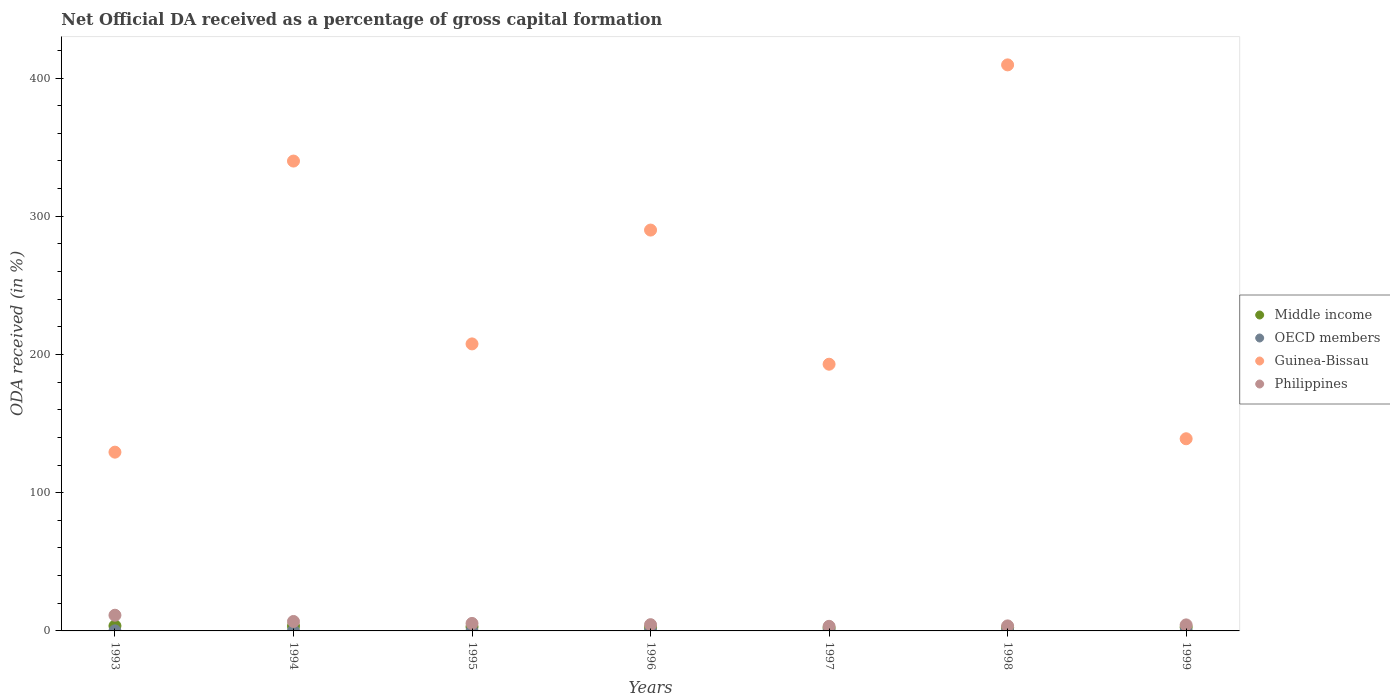How many different coloured dotlines are there?
Ensure brevity in your answer.  4. Is the number of dotlines equal to the number of legend labels?
Your answer should be compact. Yes. What is the net ODA received in Philippines in 1999?
Keep it short and to the point. 4.36. Across all years, what is the maximum net ODA received in Middle income?
Offer a terse response. 3.64. Across all years, what is the minimum net ODA received in Philippines?
Ensure brevity in your answer.  3.33. In which year was the net ODA received in OECD members maximum?
Make the answer very short. 1996. In which year was the net ODA received in Philippines minimum?
Make the answer very short. 1997. What is the total net ODA received in Guinea-Bissau in the graph?
Your answer should be compact. 1708.31. What is the difference between the net ODA received in Guinea-Bissau in 1995 and that in 1997?
Your response must be concise. 14.7. What is the difference between the net ODA received in OECD members in 1993 and the net ODA received in Philippines in 1999?
Your answer should be compact. -4.31. What is the average net ODA received in Philippines per year?
Give a very brief answer. 5.64. In the year 1997, what is the difference between the net ODA received in Philippines and net ODA received in Guinea-Bissau?
Give a very brief answer. -189.61. What is the ratio of the net ODA received in OECD members in 1996 to that in 1997?
Provide a succinct answer. 16.59. Is the difference between the net ODA received in Philippines in 1993 and 1997 greater than the difference between the net ODA received in Guinea-Bissau in 1993 and 1997?
Provide a succinct answer. Yes. What is the difference between the highest and the second highest net ODA received in Philippines?
Your answer should be very brief. 4.52. What is the difference between the highest and the lowest net ODA received in Guinea-Bissau?
Your answer should be compact. 280.17. In how many years, is the net ODA received in Guinea-Bissau greater than the average net ODA received in Guinea-Bissau taken over all years?
Make the answer very short. 3. Is it the case that in every year, the sum of the net ODA received in Middle income and net ODA received in Philippines  is greater than the net ODA received in OECD members?
Provide a short and direct response. Yes. How many dotlines are there?
Make the answer very short. 4. Are the values on the major ticks of Y-axis written in scientific E-notation?
Give a very brief answer. No. Does the graph contain grids?
Your answer should be very brief. No. How are the legend labels stacked?
Make the answer very short. Vertical. What is the title of the graph?
Keep it short and to the point. Net Official DA received as a percentage of gross capital formation. Does "Pacific island small states" appear as one of the legend labels in the graph?
Offer a terse response. No. What is the label or title of the Y-axis?
Make the answer very short. ODA received (in %). What is the ODA received (in %) in Middle income in 1993?
Provide a short and direct response. 3.64. What is the ODA received (in %) of OECD members in 1993?
Your answer should be very brief. 0.05. What is the ODA received (in %) of Guinea-Bissau in 1993?
Offer a very short reply. 129.32. What is the ODA received (in %) of Philippines in 1993?
Your answer should be compact. 11.35. What is the ODA received (in %) of Middle income in 1994?
Ensure brevity in your answer.  3.43. What is the ODA received (in %) of OECD members in 1994?
Give a very brief answer. 0.04. What is the ODA received (in %) in Guinea-Bissau in 1994?
Your answer should be compact. 339.91. What is the ODA received (in %) in Philippines in 1994?
Make the answer very short. 6.83. What is the ODA received (in %) of Middle income in 1995?
Give a very brief answer. 2.93. What is the ODA received (in %) of OECD members in 1995?
Make the answer very short. 0.02. What is the ODA received (in %) of Guinea-Bissau in 1995?
Ensure brevity in your answer.  207.64. What is the ODA received (in %) in Philippines in 1995?
Provide a short and direct response. 5.42. What is the ODA received (in %) in Middle income in 1996?
Your response must be concise. 2.51. What is the ODA received (in %) in OECD members in 1996?
Give a very brief answer. 0.05. What is the ODA received (in %) in Guinea-Bissau in 1996?
Your response must be concise. 289.99. What is the ODA received (in %) of Philippines in 1996?
Your answer should be very brief. 4.51. What is the ODA received (in %) of Middle income in 1997?
Keep it short and to the point. 2.09. What is the ODA received (in %) of OECD members in 1997?
Provide a succinct answer. 0. What is the ODA received (in %) of Guinea-Bissau in 1997?
Provide a short and direct response. 192.94. What is the ODA received (in %) of Philippines in 1997?
Keep it short and to the point. 3.33. What is the ODA received (in %) of Middle income in 1998?
Your response must be concise. 2.4. What is the ODA received (in %) of OECD members in 1998?
Make the answer very short. 0. What is the ODA received (in %) of Guinea-Bissau in 1998?
Provide a short and direct response. 409.5. What is the ODA received (in %) in Philippines in 1998?
Ensure brevity in your answer.  3.64. What is the ODA received (in %) in Middle income in 1999?
Your answer should be compact. 2.69. What is the ODA received (in %) of OECD members in 1999?
Offer a very short reply. 0. What is the ODA received (in %) in Guinea-Bissau in 1999?
Keep it short and to the point. 139.02. What is the ODA received (in %) in Philippines in 1999?
Offer a terse response. 4.36. Across all years, what is the maximum ODA received (in %) of Middle income?
Ensure brevity in your answer.  3.64. Across all years, what is the maximum ODA received (in %) of OECD members?
Ensure brevity in your answer.  0.05. Across all years, what is the maximum ODA received (in %) of Guinea-Bissau?
Your answer should be very brief. 409.5. Across all years, what is the maximum ODA received (in %) in Philippines?
Make the answer very short. 11.35. Across all years, what is the minimum ODA received (in %) of Middle income?
Make the answer very short. 2.09. Across all years, what is the minimum ODA received (in %) of OECD members?
Your response must be concise. 0. Across all years, what is the minimum ODA received (in %) of Guinea-Bissau?
Offer a terse response. 129.32. Across all years, what is the minimum ODA received (in %) of Philippines?
Provide a succinct answer. 3.33. What is the total ODA received (in %) in Middle income in the graph?
Your answer should be very brief. 19.69. What is the total ODA received (in %) in OECD members in the graph?
Your response must be concise. 0.16. What is the total ODA received (in %) in Guinea-Bissau in the graph?
Your response must be concise. 1708.31. What is the total ODA received (in %) of Philippines in the graph?
Provide a succinct answer. 39.45. What is the difference between the ODA received (in %) in Middle income in 1993 and that in 1994?
Give a very brief answer. 0.22. What is the difference between the ODA received (in %) in OECD members in 1993 and that in 1994?
Keep it short and to the point. 0.01. What is the difference between the ODA received (in %) in Guinea-Bissau in 1993 and that in 1994?
Your answer should be compact. -210.58. What is the difference between the ODA received (in %) in Philippines in 1993 and that in 1994?
Ensure brevity in your answer.  4.52. What is the difference between the ODA received (in %) in Middle income in 1993 and that in 1995?
Provide a short and direct response. 0.71. What is the difference between the ODA received (in %) in OECD members in 1993 and that in 1995?
Keep it short and to the point. 0.02. What is the difference between the ODA received (in %) of Guinea-Bissau in 1993 and that in 1995?
Provide a succinct answer. -78.31. What is the difference between the ODA received (in %) in Philippines in 1993 and that in 1995?
Offer a terse response. 5.93. What is the difference between the ODA received (in %) in Middle income in 1993 and that in 1996?
Your answer should be compact. 1.14. What is the difference between the ODA received (in %) of OECD members in 1993 and that in 1996?
Provide a short and direct response. -0. What is the difference between the ODA received (in %) of Guinea-Bissau in 1993 and that in 1996?
Offer a terse response. -160.66. What is the difference between the ODA received (in %) of Philippines in 1993 and that in 1996?
Make the answer very short. 6.84. What is the difference between the ODA received (in %) in Middle income in 1993 and that in 1997?
Make the answer very short. 1.55. What is the difference between the ODA received (in %) of OECD members in 1993 and that in 1997?
Provide a short and direct response. 0.04. What is the difference between the ODA received (in %) in Guinea-Bissau in 1993 and that in 1997?
Your answer should be compact. -63.62. What is the difference between the ODA received (in %) of Philippines in 1993 and that in 1997?
Provide a succinct answer. 8.02. What is the difference between the ODA received (in %) of Middle income in 1993 and that in 1998?
Offer a terse response. 1.25. What is the difference between the ODA received (in %) in OECD members in 1993 and that in 1998?
Give a very brief answer. 0.04. What is the difference between the ODA received (in %) of Guinea-Bissau in 1993 and that in 1998?
Ensure brevity in your answer.  -280.17. What is the difference between the ODA received (in %) in Philippines in 1993 and that in 1998?
Your answer should be compact. 7.72. What is the difference between the ODA received (in %) of Middle income in 1993 and that in 1999?
Give a very brief answer. 0.95. What is the difference between the ODA received (in %) in OECD members in 1993 and that in 1999?
Provide a short and direct response. 0.05. What is the difference between the ODA received (in %) in Guinea-Bissau in 1993 and that in 1999?
Your answer should be very brief. -9.7. What is the difference between the ODA received (in %) of Philippines in 1993 and that in 1999?
Your answer should be compact. 6.99. What is the difference between the ODA received (in %) of Middle income in 1994 and that in 1995?
Offer a terse response. 0.5. What is the difference between the ODA received (in %) in OECD members in 1994 and that in 1995?
Keep it short and to the point. 0.01. What is the difference between the ODA received (in %) in Guinea-Bissau in 1994 and that in 1995?
Keep it short and to the point. 132.27. What is the difference between the ODA received (in %) in Philippines in 1994 and that in 1995?
Your answer should be very brief. 1.41. What is the difference between the ODA received (in %) in Middle income in 1994 and that in 1996?
Ensure brevity in your answer.  0.92. What is the difference between the ODA received (in %) in OECD members in 1994 and that in 1996?
Your response must be concise. -0.01. What is the difference between the ODA received (in %) of Guinea-Bissau in 1994 and that in 1996?
Your response must be concise. 49.92. What is the difference between the ODA received (in %) in Philippines in 1994 and that in 1996?
Give a very brief answer. 2.32. What is the difference between the ODA received (in %) in Middle income in 1994 and that in 1997?
Provide a succinct answer. 1.33. What is the difference between the ODA received (in %) of OECD members in 1994 and that in 1997?
Ensure brevity in your answer.  0.03. What is the difference between the ODA received (in %) of Guinea-Bissau in 1994 and that in 1997?
Your response must be concise. 146.97. What is the difference between the ODA received (in %) of Philippines in 1994 and that in 1997?
Your response must be concise. 3.5. What is the difference between the ODA received (in %) in Middle income in 1994 and that in 1998?
Ensure brevity in your answer.  1.03. What is the difference between the ODA received (in %) of OECD members in 1994 and that in 1998?
Offer a terse response. 0.03. What is the difference between the ODA received (in %) of Guinea-Bissau in 1994 and that in 1998?
Offer a terse response. -69.59. What is the difference between the ODA received (in %) of Philippines in 1994 and that in 1998?
Your answer should be compact. 3.2. What is the difference between the ODA received (in %) in Middle income in 1994 and that in 1999?
Your response must be concise. 0.74. What is the difference between the ODA received (in %) in OECD members in 1994 and that in 1999?
Provide a succinct answer. 0.04. What is the difference between the ODA received (in %) of Guinea-Bissau in 1994 and that in 1999?
Keep it short and to the point. 200.89. What is the difference between the ODA received (in %) of Philippines in 1994 and that in 1999?
Give a very brief answer. 2.47. What is the difference between the ODA received (in %) in Middle income in 1995 and that in 1996?
Ensure brevity in your answer.  0.42. What is the difference between the ODA received (in %) in OECD members in 1995 and that in 1996?
Ensure brevity in your answer.  -0.03. What is the difference between the ODA received (in %) of Guinea-Bissau in 1995 and that in 1996?
Offer a terse response. -82.35. What is the difference between the ODA received (in %) in Philippines in 1995 and that in 1996?
Keep it short and to the point. 0.91. What is the difference between the ODA received (in %) of Middle income in 1995 and that in 1997?
Your answer should be very brief. 0.84. What is the difference between the ODA received (in %) in OECD members in 1995 and that in 1997?
Your answer should be very brief. 0.02. What is the difference between the ODA received (in %) of Guinea-Bissau in 1995 and that in 1997?
Your response must be concise. 14.7. What is the difference between the ODA received (in %) in Philippines in 1995 and that in 1997?
Offer a very short reply. 2.09. What is the difference between the ODA received (in %) in Middle income in 1995 and that in 1998?
Give a very brief answer. 0.53. What is the difference between the ODA received (in %) of OECD members in 1995 and that in 1998?
Your response must be concise. 0.02. What is the difference between the ODA received (in %) of Guinea-Bissau in 1995 and that in 1998?
Offer a very short reply. -201.86. What is the difference between the ODA received (in %) in Philippines in 1995 and that in 1998?
Give a very brief answer. 1.79. What is the difference between the ODA received (in %) of Middle income in 1995 and that in 1999?
Give a very brief answer. 0.24. What is the difference between the ODA received (in %) in OECD members in 1995 and that in 1999?
Ensure brevity in your answer.  0.02. What is the difference between the ODA received (in %) of Guinea-Bissau in 1995 and that in 1999?
Keep it short and to the point. 68.62. What is the difference between the ODA received (in %) in Philippines in 1995 and that in 1999?
Provide a succinct answer. 1.06. What is the difference between the ODA received (in %) in Middle income in 1996 and that in 1997?
Ensure brevity in your answer.  0.41. What is the difference between the ODA received (in %) in OECD members in 1996 and that in 1997?
Provide a short and direct response. 0.05. What is the difference between the ODA received (in %) of Guinea-Bissau in 1996 and that in 1997?
Your response must be concise. 97.05. What is the difference between the ODA received (in %) in Philippines in 1996 and that in 1997?
Your response must be concise. 1.18. What is the difference between the ODA received (in %) of Middle income in 1996 and that in 1998?
Offer a very short reply. 0.11. What is the difference between the ODA received (in %) of OECD members in 1996 and that in 1998?
Keep it short and to the point. 0.05. What is the difference between the ODA received (in %) in Guinea-Bissau in 1996 and that in 1998?
Your answer should be very brief. -119.51. What is the difference between the ODA received (in %) in Philippines in 1996 and that in 1998?
Your answer should be compact. 0.88. What is the difference between the ODA received (in %) in Middle income in 1996 and that in 1999?
Keep it short and to the point. -0.18. What is the difference between the ODA received (in %) of OECD members in 1996 and that in 1999?
Your answer should be compact. 0.05. What is the difference between the ODA received (in %) in Guinea-Bissau in 1996 and that in 1999?
Ensure brevity in your answer.  150.97. What is the difference between the ODA received (in %) of Philippines in 1996 and that in 1999?
Keep it short and to the point. 0.15. What is the difference between the ODA received (in %) of Middle income in 1997 and that in 1998?
Provide a succinct answer. -0.3. What is the difference between the ODA received (in %) in OECD members in 1997 and that in 1998?
Make the answer very short. 0. What is the difference between the ODA received (in %) in Guinea-Bissau in 1997 and that in 1998?
Make the answer very short. -216.56. What is the difference between the ODA received (in %) in Philippines in 1997 and that in 1998?
Your response must be concise. -0.3. What is the difference between the ODA received (in %) in Middle income in 1997 and that in 1999?
Provide a succinct answer. -0.6. What is the difference between the ODA received (in %) in OECD members in 1997 and that in 1999?
Keep it short and to the point. 0. What is the difference between the ODA received (in %) in Guinea-Bissau in 1997 and that in 1999?
Provide a succinct answer. 53.92. What is the difference between the ODA received (in %) in Philippines in 1997 and that in 1999?
Give a very brief answer. -1.03. What is the difference between the ODA received (in %) of Middle income in 1998 and that in 1999?
Your response must be concise. -0.29. What is the difference between the ODA received (in %) in OECD members in 1998 and that in 1999?
Ensure brevity in your answer.  0. What is the difference between the ODA received (in %) of Guinea-Bissau in 1998 and that in 1999?
Offer a very short reply. 270.48. What is the difference between the ODA received (in %) of Philippines in 1998 and that in 1999?
Keep it short and to the point. -0.73. What is the difference between the ODA received (in %) in Middle income in 1993 and the ODA received (in %) in OECD members in 1994?
Keep it short and to the point. 3.61. What is the difference between the ODA received (in %) of Middle income in 1993 and the ODA received (in %) of Guinea-Bissau in 1994?
Keep it short and to the point. -336.26. What is the difference between the ODA received (in %) in Middle income in 1993 and the ODA received (in %) in Philippines in 1994?
Provide a succinct answer. -3.19. What is the difference between the ODA received (in %) of OECD members in 1993 and the ODA received (in %) of Guinea-Bissau in 1994?
Your answer should be very brief. -339.86. What is the difference between the ODA received (in %) of OECD members in 1993 and the ODA received (in %) of Philippines in 1994?
Keep it short and to the point. -6.79. What is the difference between the ODA received (in %) in Guinea-Bissau in 1993 and the ODA received (in %) in Philippines in 1994?
Offer a terse response. 122.49. What is the difference between the ODA received (in %) of Middle income in 1993 and the ODA received (in %) of OECD members in 1995?
Offer a terse response. 3.62. What is the difference between the ODA received (in %) in Middle income in 1993 and the ODA received (in %) in Guinea-Bissau in 1995?
Provide a succinct answer. -203.99. What is the difference between the ODA received (in %) of Middle income in 1993 and the ODA received (in %) of Philippines in 1995?
Provide a succinct answer. -1.78. What is the difference between the ODA received (in %) in OECD members in 1993 and the ODA received (in %) in Guinea-Bissau in 1995?
Make the answer very short. -207.59. What is the difference between the ODA received (in %) in OECD members in 1993 and the ODA received (in %) in Philippines in 1995?
Make the answer very short. -5.38. What is the difference between the ODA received (in %) of Guinea-Bissau in 1993 and the ODA received (in %) of Philippines in 1995?
Provide a succinct answer. 123.9. What is the difference between the ODA received (in %) of Middle income in 1993 and the ODA received (in %) of OECD members in 1996?
Your answer should be compact. 3.6. What is the difference between the ODA received (in %) of Middle income in 1993 and the ODA received (in %) of Guinea-Bissau in 1996?
Your answer should be very brief. -286.34. What is the difference between the ODA received (in %) of Middle income in 1993 and the ODA received (in %) of Philippines in 1996?
Provide a short and direct response. -0.87. What is the difference between the ODA received (in %) of OECD members in 1993 and the ODA received (in %) of Guinea-Bissau in 1996?
Offer a very short reply. -289.94. What is the difference between the ODA received (in %) of OECD members in 1993 and the ODA received (in %) of Philippines in 1996?
Ensure brevity in your answer.  -4.47. What is the difference between the ODA received (in %) in Guinea-Bissau in 1993 and the ODA received (in %) in Philippines in 1996?
Provide a short and direct response. 124.81. What is the difference between the ODA received (in %) of Middle income in 1993 and the ODA received (in %) of OECD members in 1997?
Give a very brief answer. 3.64. What is the difference between the ODA received (in %) in Middle income in 1993 and the ODA received (in %) in Guinea-Bissau in 1997?
Make the answer very short. -189.3. What is the difference between the ODA received (in %) of Middle income in 1993 and the ODA received (in %) of Philippines in 1997?
Your answer should be very brief. 0.31. What is the difference between the ODA received (in %) in OECD members in 1993 and the ODA received (in %) in Guinea-Bissau in 1997?
Provide a succinct answer. -192.89. What is the difference between the ODA received (in %) in OECD members in 1993 and the ODA received (in %) in Philippines in 1997?
Your answer should be very brief. -3.29. What is the difference between the ODA received (in %) in Guinea-Bissau in 1993 and the ODA received (in %) in Philippines in 1997?
Your response must be concise. 125.99. What is the difference between the ODA received (in %) of Middle income in 1993 and the ODA received (in %) of OECD members in 1998?
Provide a short and direct response. 3.64. What is the difference between the ODA received (in %) of Middle income in 1993 and the ODA received (in %) of Guinea-Bissau in 1998?
Give a very brief answer. -405.85. What is the difference between the ODA received (in %) of Middle income in 1993 and the ODA received (in %) of Philippines in 1998?
Your response must be concise. 0.01. What is the difference between the ODA received (in %) in OECD members in 1993 and the ODA received (in %) in Guinea-Bissau in 1998?
Offer a very short reply. -409.45. What is the difference between the ODA received (in %) of OECD members in 1993 and the ODA received (in %) of Philippines in 1998?
Keep it short and to the point. -3.59. What is the difference between the ODA received (in %) in Guinea-Bissau in 1993 and the ODA received (in %) in Philippines in 1998?
Keep it short and to the point. 125.69. What is the difference between the ODA received (in %) of Middle income in 1993 and the ODA received (in %) of OECD members in 1999?
Offer a very short reply. 3.64. What is the difference between the ODA received (in %) in Middle income in 1993 and the ODA received (in %) in Guinea-Bissau in 1999?
Ensure brevity in your answer.  -135.38. What is the difference between the ODA received (in %) in Middle income in 1993 and the ODA received (in %) in Philippines in 1999?
Provide a succinct answer. -0.72. What is the difference between the ODA received (in %) in OECD members in 1993 and the ODA received (in %) in Guinea-Bissau in 1999?
Your response must be concise. -138.97. What is the difference between the ODA received (in %) in OECD members in 1993 and the ODA received (in %) in Philippines in 1999?
Offer a very short reply. -4.31. What is the difference between the ODA received (in %) of Guinea-Bissau in 1993 and the ODA received (in %) of Philippines in 1999?
Your answer should be compact. 124.96. What is the difference between the ODA received (in %) of Middle income in 1994 and the ODA received (in %) of OECD members in 1995?
Provide a short and direct response. 3.41. What is the difference between the ODA received (in %) in Middle income in 1994 and the ODA received (in %) in Guinea-Bissau in 1995?
Your answer should be very brief. -204.21. What is the difference between the ODA received (in %) in Middle income in 1994 and the ODA received (in %) in Philippines in 1995?
Keep it short and to the point. -2. What is the difference between the ODA received (in %) of OECD members in 1994 and the ODA received (in %) of Guinea-Bissau in 1995?
Your response must be concise. -207.6. What is the difference between the ODA received (in %) in OECD members in 1994 and the ODA received (in %) in Philippines in 1995?
Your response must be concise. -5.39. What is the difference between the ODA received (in %) in Guinea-Bissau in 1994 and the ODA received (in %) in Philippines in 1995?
Your answer should be compact. 334.49. What is the difference between the ODA received (in %) of Middle income in 1994 and the ODA received (in %) of OECD members in 1996?
Offer a terse response. 3.38. What is the difference between the ODA received (in %) of Middle income in 1994 and the ODA received (in %) of Guinea-Bissau in 1996?
Provide a succinct answer. -286.56. What is the difference between the ODA received (in %) of Middle income in 1994 and the ODA received (in %) of Philippines in 1996?
Your response must be concise. -1.09. What is the difference between the ODA received (in %) of OECD members in 1994 and the ODA received (in %) of Guinea-Bissau in 1996?
Make the answer very short. -289.95. What is the difference between the ODA received (in %) of OECD members in 1994 and the ODA received (in %) of Philippines in 1996?
Your answer should be very brief. -4.48. What is the difference between the ODA received (in %) in Guinea-Bissau in 1994 and the ODA received (in %) in Philippines in 1996?
Your answer should be compact. 335.39. What is the difference between the ODA received (in %) in Middle income in 1994 and the ODA received (in %) in OECD members in 1997?
Offer a terse response. 3.42. What is the difference between the ODA received (in %) of Middle income in 1994 and the ODA received (in %) of Guinea-Bissau in 1997?
Your answer should be very brief. -189.51. What is the difference between the ODA received (in %) in Middle income in 1994 and the ODA received (in %) in Philippines in 1997?
Give a very brief answer. 0.09. What is the difference between the ODA received (in %) in OECD members in 1994 and the ODA received (in %) in Guinea-Bissau in 1997?
Offer a very short reply. -192.9. What is the difference between the ODA received (in %) in OECD members in 1994 and the ODA received (in %) in Philippines in 1997?
Offer a very short reply. -3.3. What is the difference between the ODA received (in %) of Guinea-Bissau in 1994 and the ODA received (in %) of Philippines in 1997?
Provide a short and direct response. 336.58. What is the difference between the ODA received (in %) of Middle income in 1994 and the ODA received (in %) of OECD members in 1998?
Offer a terse response. 3.42. What is the difference between the ODA received (in %) in Middle income in 1994 and the ODA received (in %) in Guinea-Bissau in 1998?
Offer a very short reply. -406.07. What is the difference between the ODA received (in %) in Middle income in 1994 and the ODA received (in %) in Philippines in 1998?
Provide a succinct answer. -0.21. What is the difference between the ODA received (in %) in OECD members in 1994 and the ODA received (in %) in Guinea-Bissau in 1998?
Your response must be concise. -409.46. What is the difference between the ODA received (in %) in OECD members in 1994 and the ODA received (in %) in Philippines in 1998?
Keep it short and to the point. -3.6. What is the difference between the ODA received (in %) in Guinea-Bissau in 1994 and the ODA received (in %) in Philippines in 1998?
Provide a succinct answer. 336.27. What is the difference between the ODA received (in %) in Middle income in 1994 and the ODA received (in %) in OECD members in 1999?
Your response must be concise. 3.43. What is the difference between the ODA received (in %) in Middle income in 1994 and the ODA received (in %) in Guinea-Bissau in 1999?
Your response must be concise. -135.59. What is the difference between the ODA received (in %) in Middle income in 1994 and the ODA received (in %) in Philippines in 1999?
Your response must be concise. -0.93. What is the difference between the ODA received (in %) of OECD members in 1994 and the ODA received (in %) of Guinea-Bissau in 1999?
Your answer should be very brief. -138.98. What is the difference between the ODA received (in %) in OECD members in 1994 and the ODA received (in %) in Philippines in 1999?
Offer a terse response. -4.32. What is the difference between the ODA received (in %) in Guinea-Bissau in 1994 and the ODA received (in %) in Philippines in 1999?
Offer a terse response. 335.55. What is the difference between the ODA received (in %) of Middle income in 1995 and the ODA received (in %) of OECD members in 1996?
Offer a very short reply. 2.88. What is the difference between the ODA received (in %) in Middle income in 1995 and the ODA received (in %) in Guinea-Bissau in 1996?
Provide a succinct answer. -287.06. What is the difference between the ODA received (in %) in Middle income in 1995 and the ODA received (in %) in Philippines in 1996?
Ensure brevity in your answer.  -1.58. What is the difference between the ODA received (in %) in OECD members in 1995 and the ODA received (in %) in Guinea-Bissau in 1996?
Provide a succinct answer. -289.96. What is the difference between the ODA received (in %) in OECD members in 1995 and the ODA received (in %) in Philippines in 1996?
Provide a succinct answer. -4.49. What is the difference between the ODA received (in %) of Guinea-Bissau in 1995 and the ODA received (in %) of Philippines in 1996?
Give a very brief answer. 203.12. What is the difference between the ODA received (in %) of Middle income in 1995 and the ODA received (in %) of OECD members in 1997?
Offer a terse response. 2.93. What is the difference between the ODA received (in %) of Middle income in 1995 and the ODA received (in %) of Guinea-Bissau in 1997?
Provide a short and direct response. -190.01. What is the difference between the ODA received (in %) in Middle income in 1995 and the ODA received (in %) in Philippines in 1997?
Your answer should be compact. -0.4. What is the difference between the ODA received (in %) in OECD members in 1995 and the ODA received (in %) in Guinea-Bissau in 1997?
Offer a terse response. -192.92. What is the difference between the ODA received (in %) of OECD members in 1995 and the ODA received (in %) of Philippines in 1997?
Your answer should be compact. -3.31. What is the difference between the ODA received (in %) in Guinea-Bissau in 1995 and the ODA received (in %) in Philippines in 1997?
Ensure brevity in your answer.  204.3. What is the difference between the ODA received (in %) of Middle income in 1995 and the ODA received (in %) of OECD members in 1998?
Keep it short and to the point. 2.93. What is the difference between the ODA received (in %) of Middle income in 1995 and the ODA received (in %) of Guinea-Bissau in 1998?
Give a very brief answer. -406.57. What is the difference between the ODA received (in %) in Middle income in 1995 and the ODA received (in %) in Philippines in 1998?
Keep it short and to the point. -0.71. What is the difference between the ODA received (in %) in OECD members in 1995 and the ODA received (in %) in Guinea-Bissau in 1998?
Make the answer very short. -409.47. What is the difference between the ODA received (in %) in OECD members in 1995 and the ODA received (in %) in Philippines in 1998?
Your response must be concise. -3.61. What is the difference between the ODA received (in %) of Guinea-Bissau in 1995 and the ODA received (in %) of Philippines in 1998?
Provide a succinct answer. 204. What is the difference between the ODA received (in %) of Middle income in 1995 and the ODA received (in %) of OECD members in 1999?
Give a very brief answer. 2.93. What is the difference between the ODA received (in %) of Middle income in 1995 and the ODA received (in %) of Guinea-Bissau in 1999?
Make the answer very short. -136.09. What is the difference between the ODA received (in %) of Middle income in 1995 and the ODA received (in %) of Philippines in 1999?
Provide a short and direct response. -1.43. What is the difference between the ODA received (in %) of OECD members in 1995 and the ODA received (in %) of Guinea-Bissau in 1999?
Provide a succinct answer. -139. What is the difference between the ODA received (in %) in OECD members in 1995 and the ODA received (in %) in Philippines in 1999?
Give a very brief answer. -4.34. What is the difference between the ODA received (in %) of Guinea-Bissau in 1995 and the ODA received (in %) of Philippines in 1999?
Ensure brevity in your answer.  203.28. What is the difference between the ODA received (in %) in Middle income in 1996 and the ODA received (in %) in OECD members in 1997?
Provide a succinct answer. 2.51. What is the difference between the ODA received (in %) of Middle income in 1996 and the ODA received (in %) of Guinea-Bissau in 1997?
Keep it short and to the point. -190.43. What is the difference between the ODA received (in %) of Middle income in 1996 and the ODA received (in %) of Philippines in 1997?
Offer a terse response. -0.82. What is the difference between the ODA received (in %) of OECD members in 1996 and the ODA received (in %) of Guinea-Bissau in 1997?
Your answer should be very brief. -192.89. What is the difference between the ODA received (in %) in OECD members in 1996 and the ODA received (in %) in Philippines in 1997?
Your answer should be very brief. -3.28. What is the difference between the ODA received (in %) in Guinea-Bissau in 1996 and the ODA received (in %) in Philippines in 1997?
Offer a very short reply. 286.65. What is the difference between the ODA received (in %) in Middle income in 1996 and the ODA received (in %) in OECD members in 1998?
Your answer should be compact. 2.51. What is the difference between the ODA received (in %) of Middle income in 1996 and the ODA received (in %) of Guinea-Bissau in 1998?
Your answer should be compact. -406.99. What is the difference between the ODA received (in %) in Middle income in 1996 and the ODA received (in %) in Philippines in 1998?
Your answer should be very brief. -1.13. What is the difference between the ODA received (in %) in OECD members in 1996 and the ODA received (in %) in Guinea-Bissau in 1998?
Ensure brevity in your answer.  -409.45. What is the difference between the ODA received (in %) in OECD members in 1996 and the ODA received (in %) in Philippines in 1998?
Offer a terse response. -3.59. What is the difference between the ODA received (in %) in Guinea-Bissau in 1996 and the ODA received (in %) in Philippines in 1998?
Provide a short and direct response. 286.35. What is the difference between the ODA received (in %) in Middle income in 1996 and the ODA received (in %) in OECD members in 1999?
Offer a very short reply. 2.51. What is the difference between the ODA received (in %) of Middle income in 1996 and the ODA received (in %) of Guinea-Bissau in 1999?
Give a very brief answer. -136.51. What is the difference between the ODA received (in %) in Middle income in 1996 and the ODA received (in %) in Philippines in 1999?
Provide a short and direct response. -1.85. What is the difference between the ODA received (in %) in OECD members in 1996 and the ODA received (in %) in Guinea-Bissau in 1999?
Keep it short and to the point. -138.97. What is the difference between the ODA received (in %) in OECD members in 1996 and the ODA received (in %) in Philippines in 1999?
Ensure brevity in your answer.  -4.31. What is the difference between the ODA received (in %) of Guinea-Bissau in 1996 and the ODA received (in %) of Philippines in 1999?
Keep it short and to the point. 285.63. What is the difference between the ODA received (in %) of Middle income in 1997 and the ODA received (in %) of OECD members in 1998?
Make the answer very short. 2.09. What is the difference between the ODA received (in %) in Middle income in 1997 and the ODA received (in %) in Guinea-Bissau in 1998?
Keep it short and to the point. -407.4. What is the difference between the ODA received (in %) of Middle income in 1997 and the ODA received (in %) of Philippines in 1998?
Offer a very short reply. -1.54. What is the difference between the ODA received (in %) in OECD members in 1997 and the ODA received (in %) in Guinea-Bissau in 1998?
Give a very brief answer. -409.49. What is the difference between the ODA received (in %) in OECD members in 1997 and the ODA received (in %) in Philippines in 1998?
Give a very brief answer. -3.63. What is the difference between the ODA received (in %) in Guinea-Bissau in 1997 and the ODA received (in %) in Philippines in 1998?
Keep it short and to the point. 189.3. What is the difference between the ODA received (in %) in Middle income in 1997 and the ODA received (in %) in OECD members in 1999?
Offer a very short reply. 2.09. What is the difference between the ODA received (in %) in Middle income in 1997 and the ODA received (in %) in Guinea-Bissau in 1999?
Make the answer very short. -136.92. What is the difference between the ODA received (in %) in Middle income in 1997 and the ODA received (in %) in Philippines in 1999?
Provide a short and direct response. -2.27. What is the difference between the ODA received (in %) in OECD members in 1997 and the ODA received (in %) in Guinea-Bissau in 1999?
Ensure brevity in your answer.  -139.02. What is the difference between the ODA received (in %) of OECD members in 1997 and the ODA received (in %) of Philippines in 1999?
Give a very brief answer. -4.36. What is the difference between the ODA received (in %) of Guinea-Bissau in 1997 and the ODA received (in %) of Philippines in 1999?
Ensure brevity in your answer.  188.58. What is the difference between the ODA received (in %) of Middle income in 1998 and the ODA received (in %) of OECD members in 1999?
Ensure brevity in your answer.  2.4. What is the difference between the ODA received (in %) of Middle income in 1998 and the ODA received (in %) of Guinea-Bissau in 1999?
Your answer should be very brief. -136.62. What is the difference between the ODA received (in %) of Middle income in 1998 and the ODA received (in %) of Philippines in 1999?
Offer a terse response. -1.96. What is the difference between the ODA received (in %) in OECD members in 1998 and the ODA received (in %) in Guinea-Bissau in 1999?
Your answer should be compact. -139.02. What is the difference between the ODA received (in %) in OECD members in 1998 and the ODA received (in %) in Philippines in 1999?
Keep it short and to the point. -4.36. What is the difference between the ODA received (in %) of Guinea-Bissau in 1998 and the ODA received (in %) of Philippines in 1999?
Offer a very short reply. 405.13. What is the average ODA received (in %) in Middle income per year?
Offer a terse response. 2.81. What is the average ODA received (in %) of OECD members per year?
Provide a succinct answer. 0.02. What is the average ODA received (in %) in Guinea-Bissau per year?
Make the answer very short. 244.04. What is the average ODA received (in %) in Philippines per year?
Provide a succinct answer. 5.64. In the year 1993, what is the difference between the ODA received (in %) of Middle income and ODA received (in %) of OECD members?
Give a very brief answer. 3.6. In the year 1993, what is the difference between the ODA received (in %) in Middle income and ODA received (in %) in Guinea-Bissau?
Provide a short and direct response. -125.68. In the year 1993, what is the difference between the ODA received (in %) of Middle income and ODA received (in %) of Philippines?
Keep it short and to the point. -7.71. In the year 1993, what is the difference between the ODA received (in %) in OECD members and ODA received (in %) in Guinea-Bissau?
Give a very brief answer. -129.28. In the year 1993, what is the difference between the ODA received (in %) in OECD members and ODA received (in %) in Philippines?
Your answer should be compact. -11.31. In the year 1993, what is the difference between the ODA received (in %) in Guinea-Bissau and ODA received (in %) in Philippines?
Provide a short and direct response. 117.97. In the year 1994, what is the difference between the ODA received (in %) of Middle income and ODA received (in %) of OECD members?
Ensure brevity in your answer.  3.39. In the year 1994, what is the difference between the ODA received (in %) of Middle income and ODA received (in %) of Guinea-Bissau?
Offer a terse response. -336.48. In the year 1994, what is the difference between the ODA received (in %) of Middle income and ODA received (in %) of Philippines?
Your answer should be compact. -3.41. In the year 1994, what is the difference between the ODA received (in %) in OECD members and ODA received (in %) in Guinea-Bissau?
Provide a succinct answer. -339.87. In the year 1994, what is the difference between the ODA received (in %) in OECD members and ODA received (in %) in Philippines?
Offer a very short reply. -6.8. In the year 1994, what is the difference between the ODA received (in %) in Guinea-Bissau and ODA received (in %) in Philippines?
Keep it short and to the point. 333.07. In the year 1995, what is the difference between the ODA received (in %) of Middle income and ODA received (in %) of OECD members?
Ensure brevity in your answer.  2.91. In the year 1995, what is the difference between the ODA received (in %) of Middle income and ODA received (in %) of Guinea-Bissau?
Give a very brief answer. -204.71. In the year 1995, what is the difference between the ODA received (in %) of Middle income and ODA received (in %) of Philippines?
Make the answer very short. -2.49. In the year 1995, what is the difference between the ODA received (in %) in OECD members and ODA received (in %) in Guinea-Bissau?
Keep it short and to the point. -207.61. In the year 1995, what is the difference between the ODA received (in %) of OECD members and ODA received (in %) of Philippines?
Ensure brevity in your answer.  -5.4. In the year 1995, what is the difference between the ODA received (in %) of Guinea-Bissau and ODA received (in %) of Philippines?
Offer a terse response. 202.21. In the year 1996, what is the difference between the ODA received (in %) in Middle income and ODA received (in %) in OECD members?
Make the answer very short. 2.46. In the year 1996, what is the difference between the ODA received (in %) in Middle income and ODA received (in %) in Guinea-Bissau?
Offer a terse response. -287.48. In the year 1996, what is the difference between the ODA received (in %) of Middle income and ODA received (in %) of Philippines?
Make the answer very short. -2.01. In the year 1996, what is the difference between the ODA received (in %) of OECD members and ODA received (in %) of Guinea-Bissau?
Ensure brevity in your answer.  -289.94. In the year 1996, what is the difference between the ODA received (in %) of OECD members and ODA received (in %) of Philippines?
Ensure brevity in your answer.  -4.47. In the year 1996, what is the difference between the ODA received (in %) of Guinea-Bissau and ODA received (in %) of Philippines?
Provide a succinct answer. 285.47. In the year 1997, what is the difference between the ODA received (in %) of Middle income and ODA received (in %) of OECD members?
Your response must be concise. 2.09. In the year 1997, what is the difference between the ODA received (in %) of Middle income and ODA received (in %) of Guinea-Bissau?
Offer a terse response. -190.84. In the year 1997, what is the difference between the ODA received (in %) of Middle income and ODA received (in %) of Philippines?
Offer a very short reply. -1.24. In the year 1997, what is the difference between the ODA received (in %) of OECD members and ODA received (in %) of Guinea-Bissau?
Keep it short and to the point. -192.94. In the year 1997, what is the difference between the ODA received (in %) in OECD members and ODA received (in %) in Philippines?
Provide a short and direct response. -3.33. In the year 1997, what is the difference between the ODA received (in %) of Guinea-Bissau and ODA received (in %) of Philippines?
Provide a short and direct response. 189.61. In the year 1998, what is the difference between the ODA received (in %) in Middle income and ODA received (in %) in OECD members?
Ensure brevity in your answer.  2.39. In the year 1998, what is the difference between the ODA received (in %) in Middle income and ODA received (in %) in Guinea-Bissau?
Your response must be concise. -407.1. In the year 1998, what is the difference between the ODA received (in %) of Middle income and ODA received (in %) of Philippines?
Offer a terse response. -1.24. In the year 1998, what is the difference between the ODA received (in %) of OECD members and ODA received (in %) of Guinea-Bissau?
Your answer should be very brief. -409.49. In the year 1998, what is the difference between the ODA received (in %) of OECD members and ODA received (in %) of Philippines?
Ensure brevity in your answer.  -3.63. In the year 1998, what is the difference between the ODA received (in %) in Guinea-Bissau and ODA received (in %) in Philippines?
Provide a succinct answer. 405.86. In the year 1999, what is the difference between the ODA received (in %) of Middle income and ODA received (in %) of OECD members?
Make the answer very short. 2.69. In the year 1999, what is the difference between the ODA received (in %) in Middle income and ODA received (in %) in Guinea-Bissau?
Your response must be concise. -136.33. In the year 1999, what is the difference between the ODA received (in %) in Middle income and ODA received (in %) in Philippines?
Keep it short and to the point. -1.67. In the year 1999, what is the difference between the ODA received (in %) of OECD members and ODA received (in %) of Guinea-Bissau?
Give a very brief answer. -139.02. In the year 1999, what is the difference between the ODA received (in %) of OECD members and ODA received (in %) of Philippines?
Your response must be concise. -4.36. In the year 1999, what is the difference between the ODA received (in %) in Guinea-Bissau and ODA received (in %) in Philippines?
Keep it short and to the point. 134.66. What is the ratio of the ODA received (in %) in Middle income in 1993 to that in 1994?
Provide a succinct answer. 1.06. What is the ratio of the ODA received (in %) in OECD members in 1993 to that in 1994?
Your answer should be compact. 1.28. What is the ratio of the ODA received (in %) in Guinea-Bissau in 1993 to that in 1994?
Give a very brief answer. 0.38. What is the ratio of the ODA received (in %) in Philippines in 1993 to that in 1994?
Your answer should be very brief. 1.66. What is the ratio of the ODA received (in %) of Middle income in 1993 to that in 1995?
Make the answer very short. 1.24. What is the ratio of the ODA received (in %) in OECD members in 1993 to that in 1995?
Make the answer very short. 2.12. What is the ratio of the ODA received (in %) in Guinea-Bissau in 1993 to that in 1995?
Keep it short and to the point. 0.62. What is the ratio of the ODA received (in %) in Philippines in 1993 to that in 1995?
Your answer should be very brief. 2.09. What is the ratio of the ODA received (in %) in Middle income in 1993 to that in 1996?
Keep it short and to the point. 1.45. What is the ratio of the ODA received (in %) in OECD members in 1993 to that in 1996?
Keep it short and to the point. 0.96. What is the ratio of the ODA received (in %) in Guinea-Bissau in 1993 to that in 1996?
Offer a terse response. 0.45. What is the ratio of the ODA received (in %) in Philippines in 1993 to that in 1996?
Make the answer very short. 2.52. What is the ratio of the ODA received (in %) of Middle income in 1993 to that in 1997?
Make the answer very short. 1.74. What is the ratio of the ODA received (in %) of OECD members in 1993 to that in 1997?
Offer a very short reply. 15.93. What is the ratio of the ODA received (in %) in Guinea-Bissau in 1993 to that in 1997?
Provide a short and direct response. 0.67. What is the ratio of the ODA received (in %) in Philippines in 1993 to that in 1997?
Your response must be concise. 3.41. What is the ratio of the ODA received (in %) in Middle income in 1993 to that in 1998?
Your response must be concise. 1.52. What is the ratio of the ODA received (in %) in OECD members in 1993 to that in 1998?
Offer a terse response. 19.12. What is the ratio of the ODA received (in %) of Guinea-Bissau in 1993 to that in 1998?
Provide a succinct answer. 0.32. What is the ratio of the ODA received (in %) of Philippines in 1993 to that in 1998?
Offer a terse response. 3.12. What is the ratio of the ODA received (in %) of Middle income in 1993 to that in 1999?
Your response must be concise. 1.35. What is the ratio of the ODA received (in %) of OECD members in 1993 to that in 1999?
Your answer should be very brief. 31.22. What is the ratio of the ODA received (in %) of Guinea-Bissau in 1993 to that in 1999?
Provide a short and direct response. 0.93. What is the ratio of the ODA received (in %) in Philippines in 1993 to that in 1999?
Make the answer very short. 2.6. What is the ratio of the ODA received (in %) of Middle income in 1994 to that in 1995?
Ensure brevity in your answer.  1.17. What is the ratio of the ODA received (in %) in OECD members in 1994 to that in 1995?
Make the answer very short. 1.65. What is the ratio of the ODA received (in %) of Guinea-Bissau in 1994 to that in 1995?
Your answer should be very brief. 1.64. What is the ratio of the ODA received (in %) of Philippines in 1994 to that in 1995?
Give a very brief answer. 1.26. What is the ratio of the ODA received (in %) in Middle income in 1994 to that in 1996?
Keep it short and to the point. 1.37. What is the ratio of the ODA received (in %) of OECD members in 1994 to that in 1996?
Provide a succinct answer. 0.75. What is the ratio of the ODA received (in %) of Guinea-Bissau in 1994 to that in 1996?
Provide a short and direct response. 1.17. What is the ratio of the ODA received (in %) of Philippines in 1994 to that in 1996?
Give a very brief answer. 1.51. What is the ratio of the ODA received (in %) in Middle income in 1994 to that in 1997?
Make the answer very short. 1.64. What is the ratio of the ODA received (in %) in OECD members in 1994 to that in 1997?
Provide a succinct answer. 12.43. What is the ratio of the ODA received (in %) of Guinea-Bissau in 1994 to that in 1997?
Keep it short and to the point. 1.76. What is the ratio of the ODA received (in %) in Philippines in 1994 to that in 1997?
Your answer should be compact. 2.05. What is the ratio of the ODA received (in %) of Middle income in 1994 to that in 1998?
Ensure brevity in your answer.  1.43. What is the ratio of the ODA received (in %) of OECD members in 1994 to that in 1998?
Make the answer very short. 14.92. What is the ratio of the ODA received (in %) in Guinea-Bissau in 1994 to that in 1998?
Offer a terse response. 0.83. What is the ratio of the ODA received (in %) of Philippines in 1994 to that in 1998?
Your response must be concise. 1.88. What is the ratio of the ODA received (in %) of Middle income in 1994 to that in 1999?
Provide a succinct answer. 1.27. What is the ratio of the ODA received (in %) in OECD members in 1994 to that in 1999?
Give a very brief answer. 24.36. What is the ratio of the ODA received (in %) of Guinea-Bissau in 1994 to that in 1999?
Make the answer very short. 2.44. What is the ratio of the ODA received (in %) of Philippines in 1994 to that in 1999?
Ensure brevity in your answer.  1.57. What is the ratio of the ODA received (in %) in Middle income in 1995 to that in 1996?
Ensure brevity in your answer.  1.17. What is the ratio of the ODA received (in %) of OECD members in 1995 to that in 1996?
Offer a terse response. 0.45. What is the ratio of the ODA received (in %) in Guinea-Bissau in 1995 to that in 1996?
Your response must be concise. 0.72. What is the ratio of the ODA received (in %) of Philippines in 1995 to that in 1996?
Give a very brief answer. 1.2. What is the ratio of the ODA received (in %) in Middle income in 1995 to that in 1997?
Your response must be concise. 1.4. What is the ratio of the ODA received (in %) of OECD members in 1995 to that in 1997?
Ensure brevity in your answer.  7.53. What is the ratio of the ODA received (in %) of Guinea-Bissau in 1995 to that in 1997?
Keep it short and to the point. 1.08. What is the ratio of the ODA received (in %) in Philippines in 1995 to that in 1997?
Offer a very short reply. 1.63. What is the ratio of the ODA received (in %) in Middle income in 1995 to that in 1998?
Provide a succinct answer. 1.22. What is the ratio of the ODA received (in %) of OECD members in 1995 to that in 1998?
Ensure brevity in your answer.  9.04. What is the ratio of the ODA received (in %) in Guinea-Bissau in 1995 to that in 1998?
Make the answer very short. 0.51. What is the ratio of the ODA received (in %) in Philippines in 1995 to that in 1998?
Your answer should be compact. 1.49. What is the ratio of the ODA received (in %) in Middle income in 1995 to that in 1999?
Provide a succinct answer. 1.09. What is the ratio of the ODA received (in %) in OECD members in 1995 to that in 1999?
Your answer should be compact. 14.76. What is the ratio of the ODA received (in %) in Guinea-Bissau in 1995 to that in 1999?
Your response must be concise. 1.49. What is the ratio of the ODA received (in %) of Philippines in 1995 to that in 1999?
Keep it short and to the point. 1.24. What is the ratio of the ODA received (in %) in Middle income in 1996 to that in 1997?
Make the answer very short. 1.2. What is the ratio of the ODA received (in %) of OECD members in 1996 to that in 1997?
Give a very brief answer. 16.59. What is the ratio of the ODA received (in %) of Guinea-Bissau in 1996 to that in 1997?
Your answer should be compact. 1.5. What is the ratio of the ODA received (in %) in Philippines in 1996 to that in 1997?
Keep it short and to the point. 1.35. What is the ratio of the ODA received (in %) of Middle income in 1996 to that in 1998?
Keep it short and to the point. 1.05. What is the ratio of the ODA received (in %) in OECD members in 1996 to that in 1998?
Provide a succinct answer. 19.93. What is the ratio of the ODA received (in %) of Guinea-Bissau in 1996 to that in 1998?
Offer a very short reply. 0.71. What is the ratio of the ODA received (in %) in Philippines in 1996 to that in 1998?
Your response must be concise. 1.24. What is the ratio of the ODA received (in %) in Middle income in 1996 to that in 1999?
Provide a short and direct response. 0.93. What is the ratio of the ODA received (in %) of OECD members in 1996 to that in 1999?
Your answer should be compact. 32.52. What is the ratio of the ODA received (in %) of Guinea-Bissau in 1996 to that in 1999?
Make the answer very short. 2.09. What is the ratio of the ODA received (in %) in Philippines in 1996 to that in 1999?
Offer a terse response. 1.04. What is the ratio of the ODA received (in %) of Middle income in 1997 to that in 1998?
Provide a succinct answer. 0.87. What is the ratio of the ODA received (in %) of OECD members in 1997 to that in 1998?
Ensure brevity in your answer.  1.2. What is the ratio of the ODA received (in %) in Guinea-Bissau in 1997 to that in 1998?
Make the answer very short. 0.47. What is the ratio of the ODA received (in %) of Philippines in 1997 to that in 1998?
Provide a short and direct response. 0.92. What is the ratio of the ODA received (in %) in Middle income in 1997 to that in 1999?
Your response must be concise. 0.78. What is the ratio of the ODA received (in %) of OECD members in 1997 to that in 1999?
Make the answer very short. 1.96. What is the ratio of the ODA received (in %) of Guinea-Bissau in 1997 to that in 1999?
Provide a short and direct response. 1.39. What is the ratio of the ODA received (in %) of Philippines in 1997 to that in 1999?
Provide a succinct answer. 0.76. What is the ratio of the ODA received (in %) in Middle income in 1998 to that in 1999?
Give a very brief answer. 0.89. What is the ratio of the ODA received (in %) of OECD members in 1998 to that in 1999?
Offer a terse response. 1.63. What is the ratio of the ODA received (in %) of Guinea-Bissau in 1998 to that in 1999?
Give a very brief answer. 2.95. What is the ratio of the ODA received (in %) of Philippines in 1998 to that in 1999?
Ensure brevity in your answer.  0.83. What is the difference between the highest and the second highest ODA received (in %) in Middle income?
Your response must be concise. 0.22. What is the difference between the highest and the second highest ODA received (in %) of OECD members?
Give a very brief answer. 0. What is the difference between the highest and the second highest ODA received (in %) in Guinea-Bissau?
Offer a terse response. 69.59. What is the difference between the highest and the second highest ODA received (in %) of Philippines?
Give a very brief answer. 4.52. What is the difference between the highest and the lowest ODA received (in %) of Middle income?
Your answer should be very brief. 1.55. What is the difference between the highest and the lowest ODA received (in %) of OECD members?
Ensure brevity in your answer.  0.05. What is the difference between the highest and the lowest ODA received (in %) in Guinea-Bissau?
Make the answer very short. 280.17. What is the difference between the highest and the lowest ODA received (in %) in Philippines?
Offer a very short reply. 8.02. 